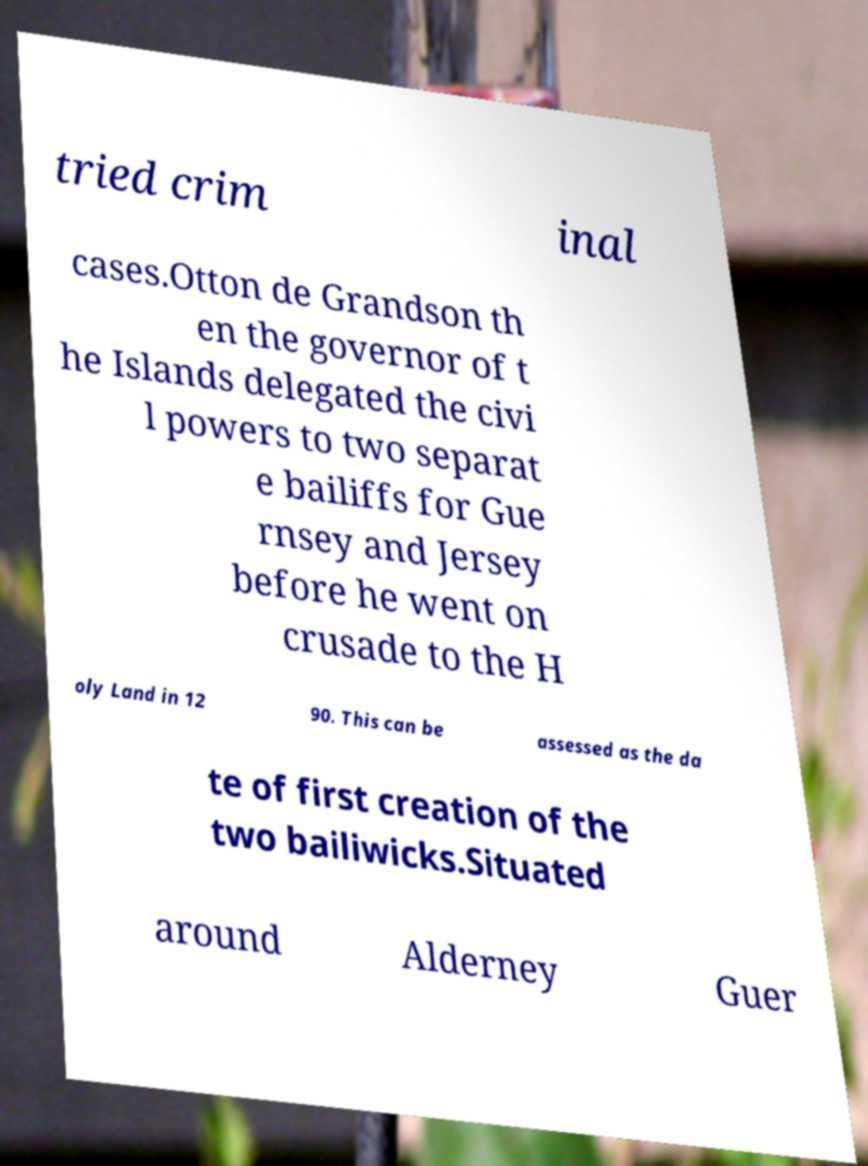Please identify and transcribe the text found in this image. tried crim inal cases.Otton de Grandson th en the governor of t he Islands delegated the civi l powers to two separat e bailiffs for Gue rnsey and Jersey before he went on crusade to the H oly Land in 12 90. This can be assessed as the da te of first creation of the two bailiwicks.Situated around Alderney Guer 